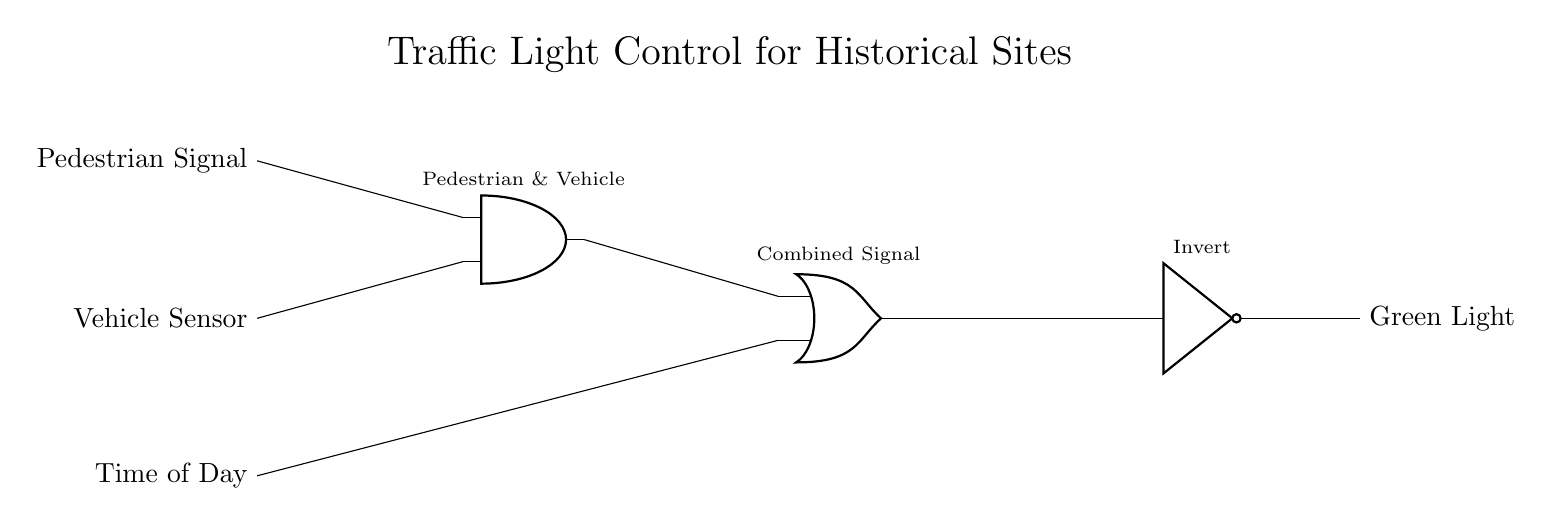What components are used in this traffic light control circuit? The circuit includes an AND gate, an OR gate, and a NOT gate, which are essential for processing the input signals and controlling the output signal.
Answer: AND gate, OR gate, NOT gate What are the input signals of the circuit? The inputs to the traffic light control circuit are the pedestrian signal, vehicle sensor, and time of day, which dictate the conditions under which the traffic light operates.
Answer: Pedestrian signal, vehicle sensor, time of day What does the output of the circuit represent? The output from the circuit is the green light, which indicates when vehicles can proceed safely, based on the logic gates' processing of the input signals.
Answer: Green light How many input signals are combined in the AND gate? The AND gate processes two input signals: the pedestrian signal and the vehicle sensor, requiring both to be active for its output to be high.
Answer: Two What is the role of the NOT gate in the circuit? The NOT gate inverts the combined signal from the OR gate, controlling the output signal of the green light, essentially making the light turn green when the combined signals indicate that it is safe to cross.
Answer: Invert What type of logic is used to determine the green light? The circuit employs a combination of AND and OR logic gates to evaluate the input signals, determining the conditions under which the green light is activated.
Answer: Combination of AND and OR logic What will happen if the pedestrian signal and vehicle sensor are both active? When both the pedestrian signal and vehicle sensor are active, the AND gate will output a high signal, which feeds into the OR gate, and subsequently into the NOT gate, influencing the behavior of the green light.
Answer: Green light will turn off 